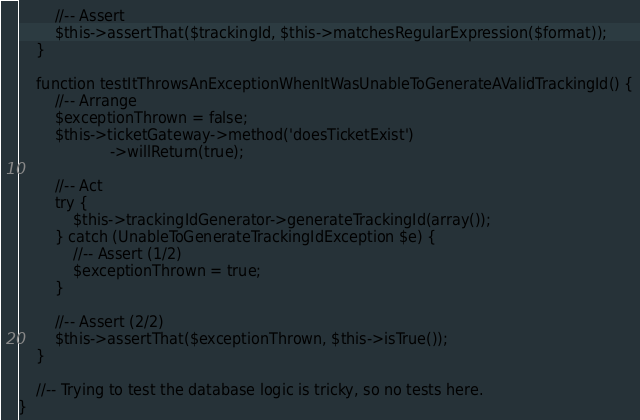<code> <loc_0><loc_0><loc_500><loc_500><_PHP_>        //-- Assert
        $this->assertThat($trackingId, $this->matchesRegularExpression($format));
    }

    function testItThrowsAnExceptionWhenItWasUnableToGenerateAValidTrackingId() {
        //-- Arrange
        $exceptionThrown = false;
        $this->ticketGateway->method('doesTicketExist')
                    ->willReturn(true);

        //-- Act
        try {
            $this->trackingIdGenerator->generateTrackingId(array());
        } catch (UnableToGenerateTrackingIdException $e) {
            //-- Assert (1/2)
            $exceptionThrown = true;
        }

        //-- Assert (2/2)
        $this->assertThat($exceptionThrown, $this->isTrue());
    }

    //-- Trying to test the database logic is tricky, so no tests here.
}
</code> 